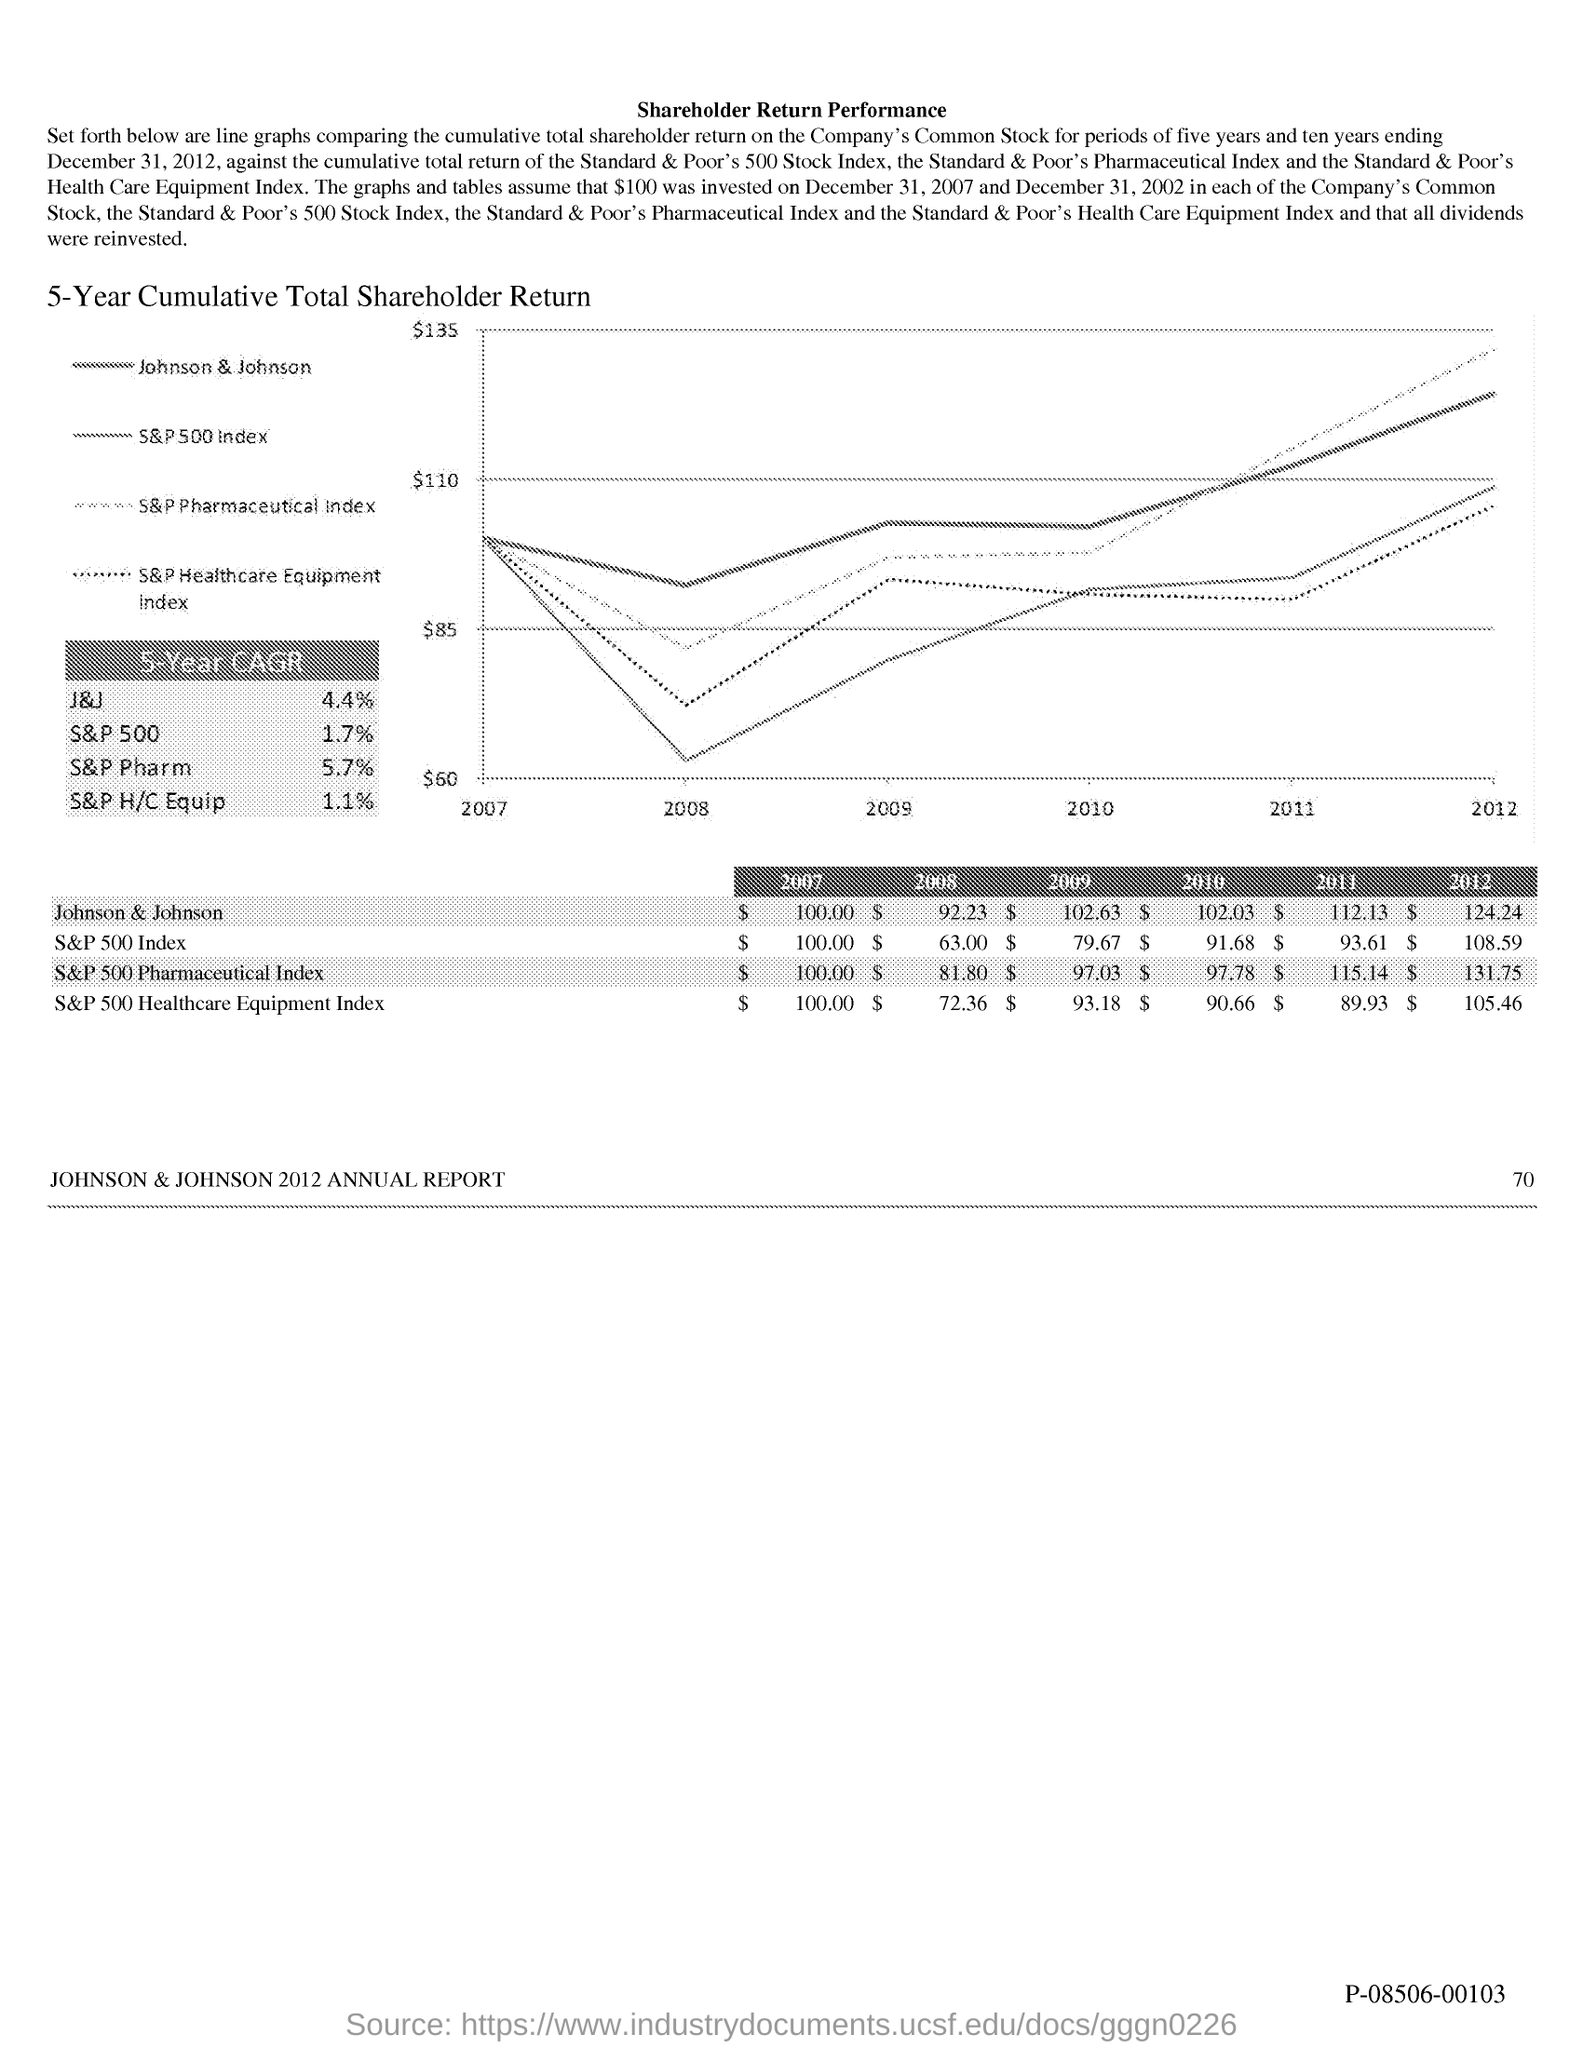List a handful of essential elements in this visual. In 2010, the value of the S&P 500 Index was $91.68. In 2010, the value of Johnson & Johnson was $102.03. In 2009, the value of Johnson & Johnson was $102.63. The value of the S&P 500 Index in 2009 was $79.67. Johnson & Johnson was valued at $124.24 in 2012. 